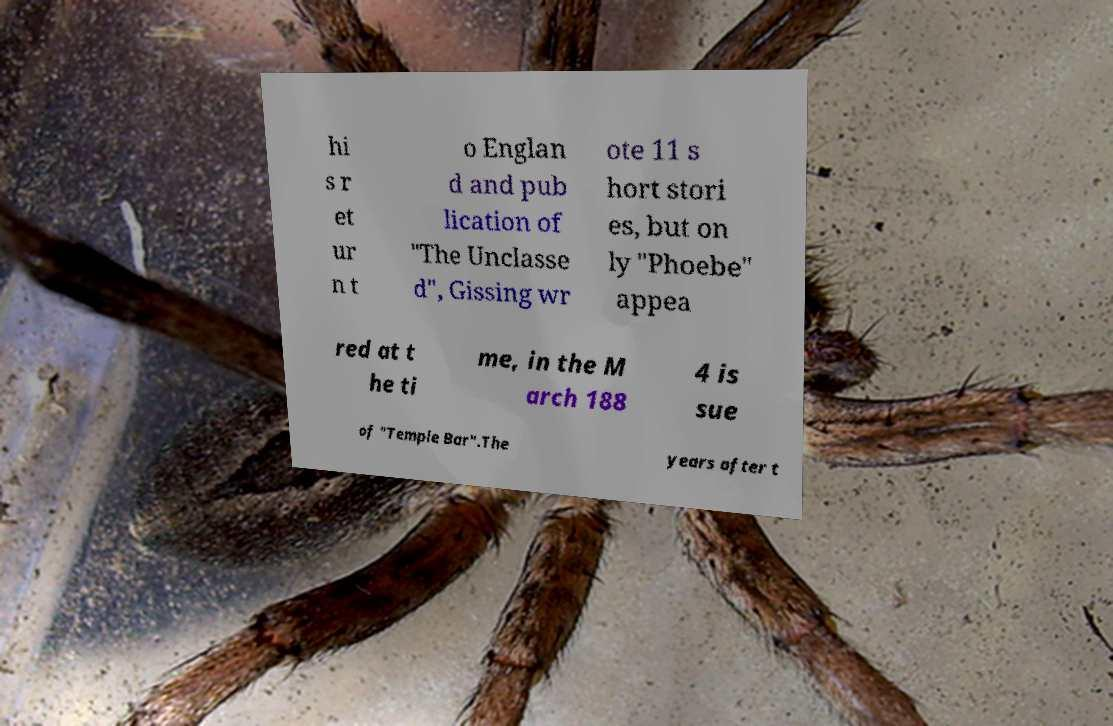Could you extract and type out the text from this image? hi s r et ur n t o Englan d and pub lication of "The Unclasse d", Gissing wr ote 11 s hort stori es, but on ly "Phoebe" appea red at t he ti me, in the M arch 188 4 is sue of "Temple Bar".The years after t 